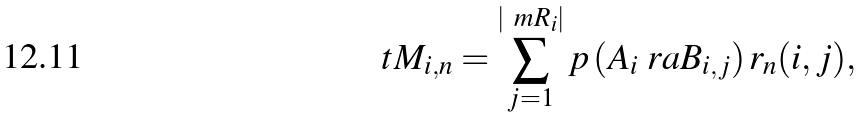Convert formula to latex. <formula><loc_0><loc_0><loc_500><loc_500>\ t M _ { i , n } = \sum _ { j = 1 } ^ { | \ m R _ { i } | } p \left ( A _ { i } \ r a B _ { i , j } \right ) r _ { n } ( i , j ) ,</formula> 